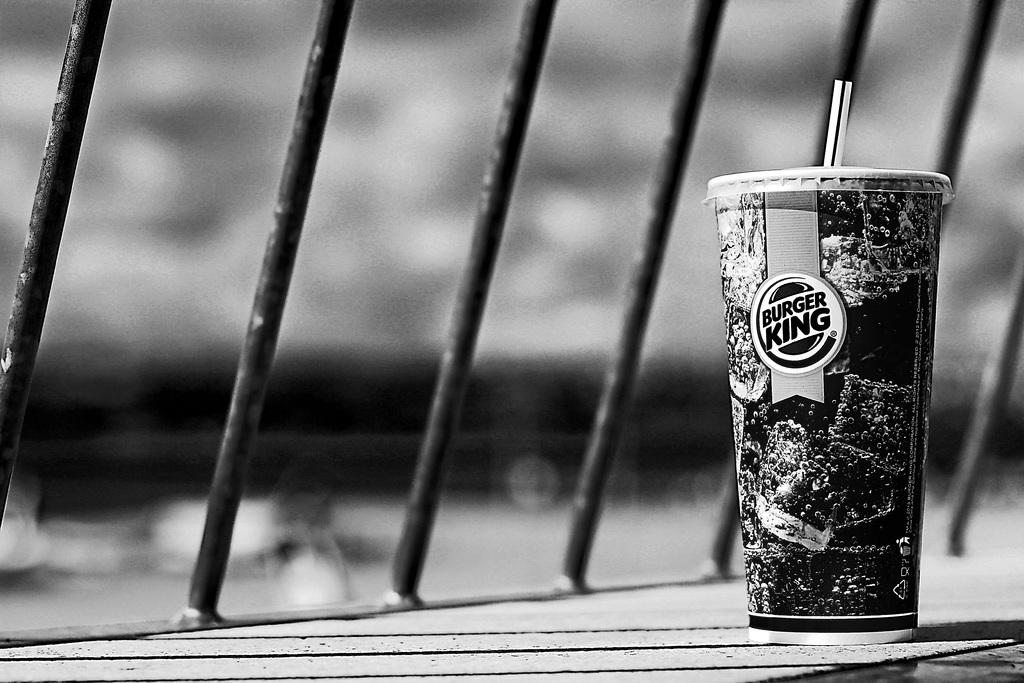What is the color scheme of the image? The image is black and white. What can be seen inside the glass in the image? There is a straw in the glass. Where is the glass located in the image? The glass is placed on a surface. What objects are beside the glass in the image? There are metal rods beside the glass. What type of vase is supporting the metal rods in the image? There is no vase present in the image, and the metal rods are not supported by any object. Is there a fire visible in the image? No, there is no fire visible in the image. 